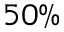Convert formula to latex. <formula><loc_0><loc_0><loc_500><loc_500>5 0 \%</formula> 